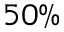Convert formula to latex. <formula><loc_0><loc_0><loc_500><loc_500>5 0 \%</formula> 